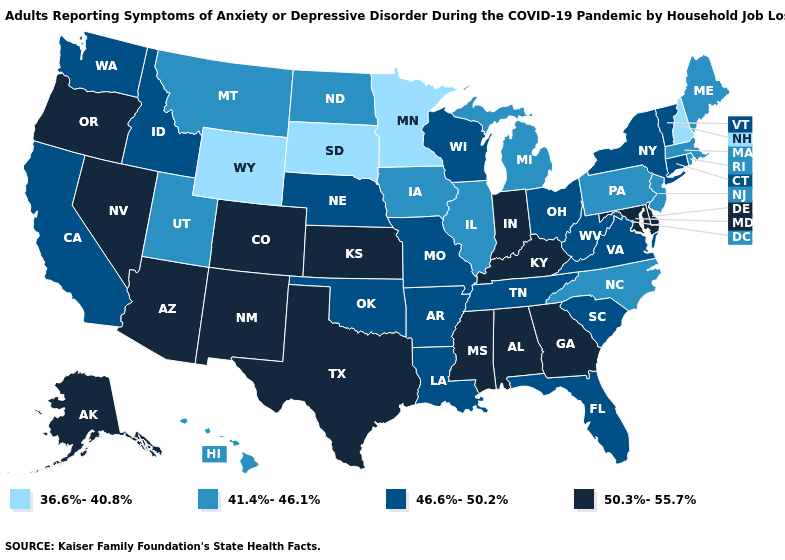Name the states that have a value in the range 41.4%-46.1%?
Write a very short answer. Hawaii, Illinois, Iowa, Maine, Massachusetts, Michigan, Montana, New Jersey, North Carolina, North Dakota, Pennsylvania, Rhode Island, Utah. Does Pennsylvania have a lower value than Montana?
Concise answer only. No. Name the states that have a value in the range 41.4%-46.1%?
Be succinct. Hawaii, Illinois, Iowa, Maine, Massachusetts, Michigan, Montana, New Jersey, North Carolina, North Dakota, Pennsylvania, Rhode Island, Utah. Name the states that have a value in the range 41.4%-46.1%?
Short answer required. Hawaii, Illinois, Iowa, Maine, Massachusetts, Michigan, Montana, New Jersey, North Carolina, North Dakota, Pennsylvania, Rhode Island, Utah. Is the legend a continuous bar?
Be succinct. No. What is the highest value in the USA?
Keep it brief. 50.3%-55.7%. Is the legend a continuous bar?
Answer briefly. No. What is the value of West Virginia?
Write a very short answer. 46.6%-50.2%. What is the value of Maine?
Answer briefly. 41.4%-46.1%. Which states have the highest value in the USA?
Write a very short answer. Alabama, Alaska, Arizona, Colorado, Delaware, Georgia, Indiana, Kansas, Kentucky, Maryland, Mississippi, Nevada, New Mexico, Oregon, Texas. Does New Jersey have the lowest value in the USA?
Be succinct. No. Name the states that have a value in the range 41.4%-46.1%?
Keep it brief. Hawaii, Illinois, Iowa, Maine, Massachusetts, Michigan, Montana, New Jersey, North Carolina, North Dakota, Pennsylvania, Rhode Island, Utah. What is the highest value in the South ?
Concise answer only. 50.3%-55.7%. Which states have the highest value in the USA?
Short answer required. Alabama, Alaska, Arizona, Colorado, Delaware, Georgia, Indiana, Kansas, Kentucky, Maryland, Mississippi, Nevada, New Mexico, Oregon, Texas. Among the states that border Montana , which have the lowest value?
Keep it brief. South Dakota, Wyoming. 